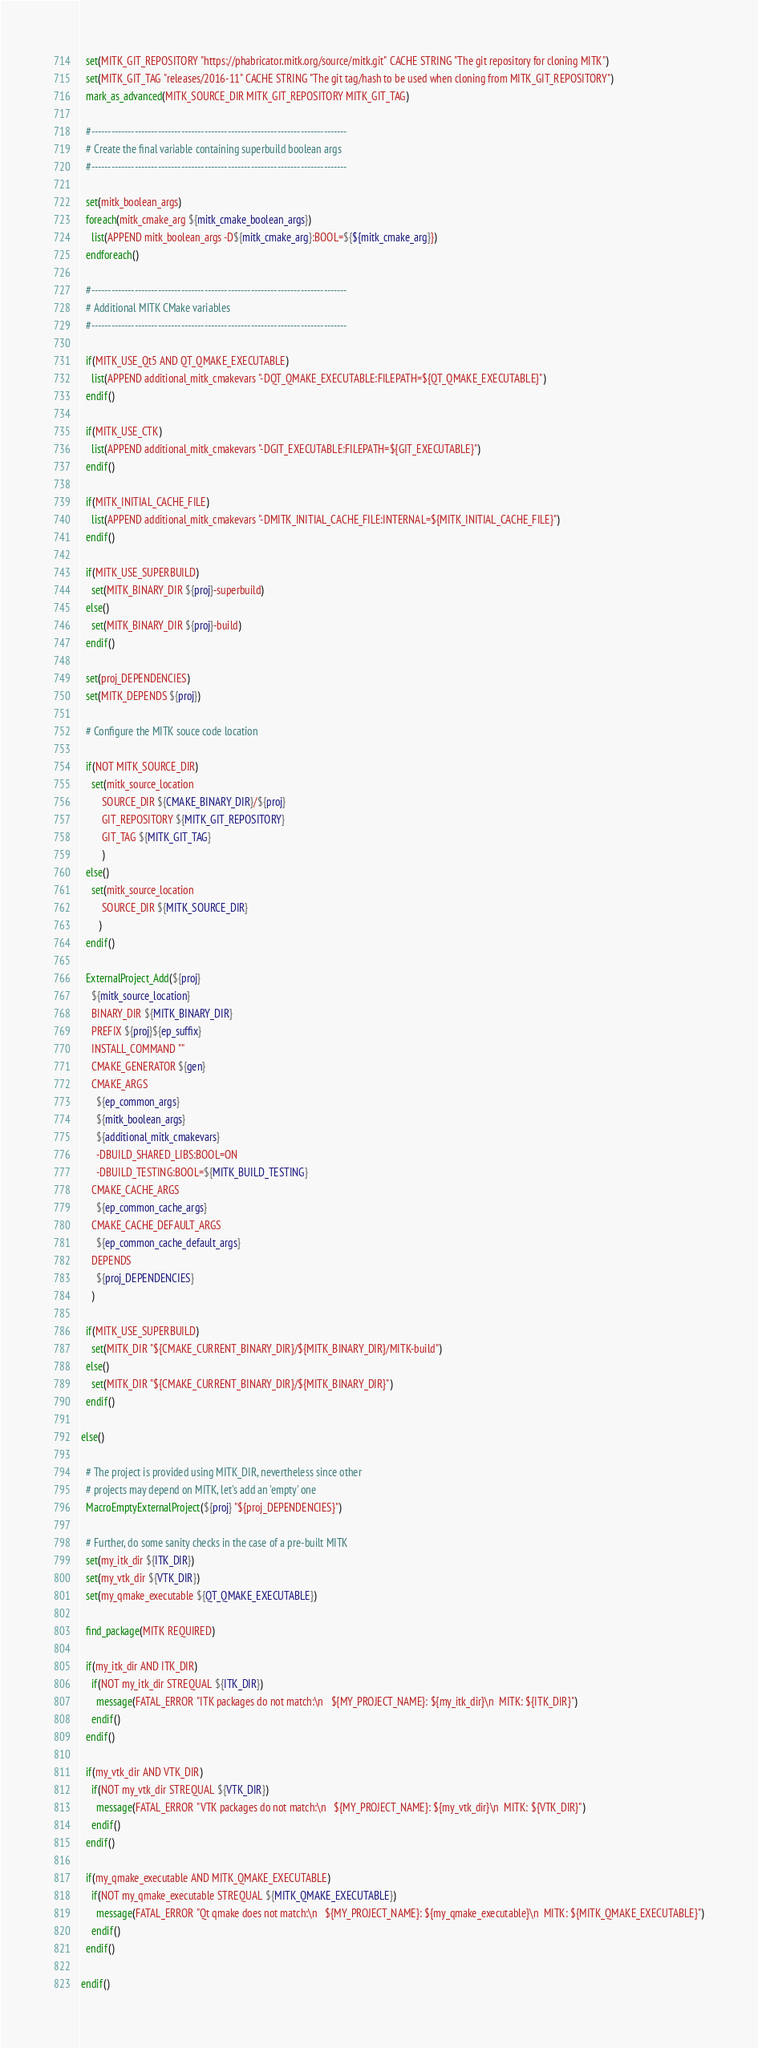Convert code to text. <code><loc_0><loc_0><loc_500><loc_500><_CMake_>  set(MITK_GIT_REPOSITORY "https://phabricator.mitk.org/source/mitk.git" CACHE STRING "The git repository for cloning MITK")
  set(MITK_GIT_TAG "releases/2016-11" CACHE STRING "The git tag/hash to be used when cloning from MITK_GIT_REPOSITORY")
  mark_as_advanced(MITK_SOURCE_DIR MITK_GIT_REPOSITORY MITK_GIT_TAG)

  #-----------------------------------------------------------------------------
  # Create the final variable containing superbuild boolean args
  #-----------------------------------------------------------------------------

  set(mitk_boolean_args)
  foreach(mitk_cmake_arg ${mitk_cmake_boolean_args})
    list(APPEND mitk_boolean_args -D${mitk_cmake_arg}:BOOL=${${mitk_cmake_arg}})
  endforeach()

  #-----------------------------------------------------------------------------
  # Additional MITK CMake variables
  #-----------------------------------------------------------------------------

  if(MITK_USE_Qt5 AND QT_QMAKE_EXECUTABLE)
    list(APPEND additional_mitk_cmakevars "-DQT_QMAKE_EXECUTABLE:FILEPATH=${QT_QMAKE_EXECUTABLE}")
  endif()

  if(MITK_USE_CTK)
    list(APPEND additional_mitk_cmakevars "-DGIT_EXECUTABLE:FILEPATH=${GIT_EXECUTABLE}")
  endif()

  if(MITK_INITIAL_CACHE_FILE)
    list(APPEND additional_mitk_cmakevars "-DMITK_INITIAL_CACHE_FILE:INTERNAL=${MITK_INITIAL_CACHE_FILE}")
  endif()

  if(MITK_USE_SUPERBUILD)
    set(MITK_BINARY_DIR ${proj}-superbuild)
  else()
    set(MITK_BINARY_DIR ${proj}-build)
  endif()

  set(proj_DEPENDENCIES)
  set(MITK_DEPENDS ${proj})

  # Configure the MITK souce code location

  if(NOT MITK_SOURCE_DIR)
    set(mitk_source_location
        SOURCE_DIR ${CMAKE_BINARY_DIR}/${proj}
        GIT_REPOSITORY ${MITK_GIT_REPOSITORY}
        GIT_TAG ${MITK_GIT_TAG}
        )
  else()
    set(mitk_source_location
        SOURCE_DIR ${MITK_SOURCE_DIR}
       )
  endif()

  ExternalProject_Add(${proj}
    ${mitk_source_location}
    BINARY_DIR ${MITK_BINARY_DIR}
    PREFIX ${proj}${ep_suffix}
    INSTALL_COMMAND ""
    CMAKE_GENERATOR ${gen}
    CMAKE_ARGS
      ${ep_common_args}
      ${mitk_boolean_args}
      ${additional_mitk_cmakevars}
      -DBUILD_SHARED_LIBS:BOOL=ON
      -DBUILD_TESTING:BOOL=${MITK_BUILD_TESTING}
    CMAKE_CACHE_ARGS
      ${ep_common_cache_args}
    CMAKE_CACHE_DEFAULT_ARGS
      ${ep_common_cache_default_args}
    DEPENDS
      ${proj_DEPENDENCIES}
    )

  if(MITK_USE_SUPERBUILD)
    set(MITK_DIR "${CMAKE_CURRENT_BINARY_DIR}/${MITK_BINARY_DIR}/MITK-build")
  else()
    set(MITK_DIR "${CMAKE_CURRENT_BINARY_DIR}/${MITK_BINARY_DIR}")
  endif()

else()

  # The project is provided using MITK_DIR, nevertheless since other
  # projects may depend on MITK, let's add an 'empty' one
  MacroEmptyExternalProject(${proj} "${proj_DEPENDENCIES}")

  # Further, do some sanity checks in the case of a pre-built MITK
  set(my_itk_dir ${ITK_DIR})
  set(my_vtk_dir ${VTK_DIR})
  set(my_qmake_executable ${QT_QMAKE_EXECUTABLE})

  find_package(MITK REQUIRED)

  if(my_itk_dir AND ITK_DIR)
    if(NOT my_itk_dir STREQUAL ${ITK_DIR})
      message(FATAL_ERROR "ITK packages do not match:\n   ${MY_PROJECT_NAME}: ${my_itk_dir}\n  MITK: ${ITK_DIR}")
    endif()
  endif()

  if(my_vtk_dir AND VTK_DIR)
    if(NOT my_vtk_dir STREQUAL ${VTK_DIR})
      message(FATAL_ERROR "VTK packages do not match:\n   ${MY_PROJECT_NAME}: ${my_vtk_dir}\n  MITK: ${VTK_DIR}")
    endif()
  endif()

  if(my_qmake_executable AND MITK_QMAKE_EXECUTABLE)
    if(NOT my_qmake_executable STREQUAL ${MITK_QMAKE_EXECUTABLE})
      message(FATAL_ERROR "Qt qmake does not match:\n   ${MY_PROJECT_NAME}: ${my_qmake_executable}\n  MITK: ${MITK_QMAKE_EXECUTABLE}")
    endif()
  endif()

endif()

</code> 